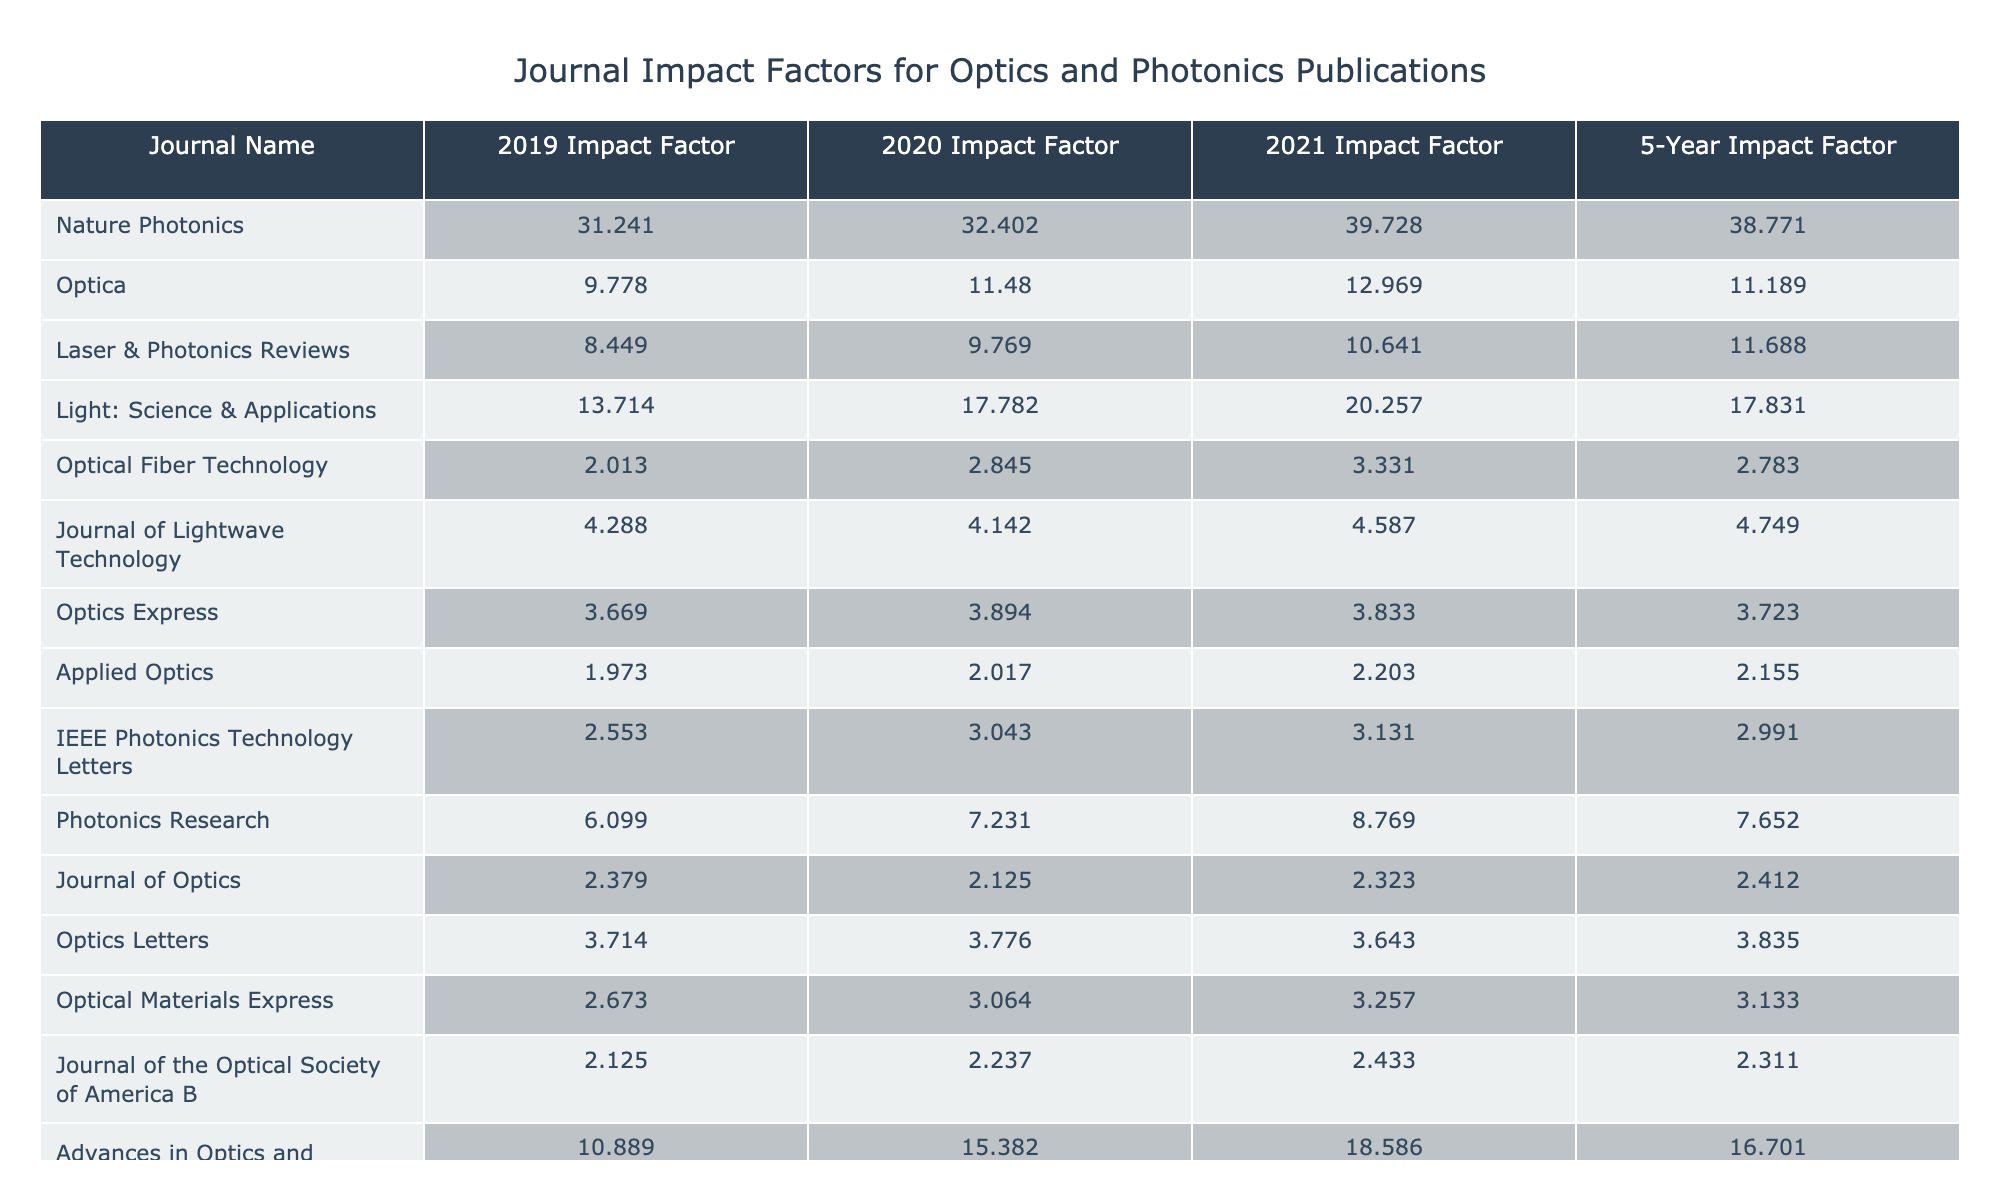What is the impact factor of Nature Photonics in 2021? The table shows that the impact factor of Nature Photonics for the year 2021 is listed as 39.728.
Answer: 39.728 Which journal had the highest 5-year impact factor? Comparing the 5-year impact factors of all journals, Nature Photonics has the highest value of 38.771.
Answer: Nature Photonics What is the average impact factor for the journal Optica from 2019 to 2021? To find the average, add the impact factors from 2019 (9.778), 2020 (11.48), and 2021 (12.969), resulting in 34.227. Dividing by 3 gives the average: 34.227 / 3 = 11.409.
Answer: 11.409 Did Optical Fiber Technology’s impact factor increase from 2019 to 2021? The impact factors for Optical Fiber Technology are 2.013 in 2019 and 3.331 in 2021, indicating an increase over this period.
Answer: Yes What is the difference between the highest and lowest impact factors in 2020? The highest impact factor in 2020 is for Nature Photonics at 32.402, and the lowest is for Applied Optics at 2.017. The difference is 32.402 - 2.017 = 30.385.
Answer: 30.385 How does the impact factor of Light: Science & Applications in 2021 compare to that of Laser & Photonics Reviews in the same year? Light: Science & Applications has an impact factor of 20.257, while Laser & Photonics Reviews has an impact factor of 10.641 in 2021. Comparing them shows that Light: Science & Applications has a higher impact factor.
Answer: Higher What was the trend of the impact factors for Advances in Optics and Photonics over the years 2019 to 2021? The impact factors for Advances in Optics and Photonics increased over the years: from 10.889 in 2019 to 15.382 in 2020, and further to 18.586 in 2021, indicating a consistent upward trend.
Answer: Increasing Which journal has the lowest 5-year impact factor, and what is its value? By examining the 5-year impact factors, Optical Fiber Technology has the lowest value at 2.783.
Answer: Optical Fiber Technology, 2.783 Is there any journal that maintained the same impact factor from 2019 to 2021? Checking the impact factors across the years, it is noted that no journal has exactly maintained the same value in all three years.
Answer: No What journal had the largest increase in impact factor from 2019 to 2021? Computing the increases, Light: Science & Applications rose from 13.714 in 2019 to 20.257 in 2021, an increase of 6.543. This is the largest increase among the journals listed.
Answer: Light: Science & Applications, 6.543 